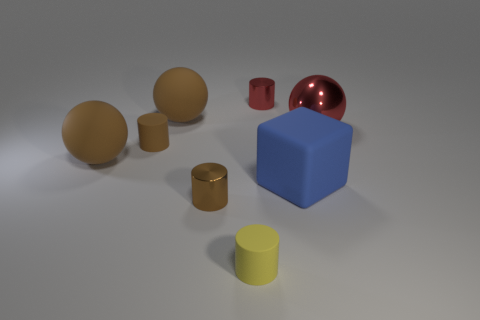How many large brown objects are there?
Give a very brief answer. 2. The small rubber cylinder that is in front of the blue block is what color?
Ensure brevity in your answer.  Yellow. The brown metal cylinder has what size?
Keep it short and to the point. Small. There is a rubber block; is its color the same as the tiny metal cylinder in front of the block?
Your response must be concise. No. There is a tiny shiny thing that is behind the rubber cylinder behind the big blue cube; what color is it?
Offer a very short reply. Red. Does the red metal object to the left of the blue block have the same shape as the small brown metal thing?
Offer a very short reply. Yes. How many big matte things are left of the blue matte cube and in front of the brown rubber cylinder?
Offer a very short reply. 1. What is the color of the tiny rubber cylinder in front of the rubber cylinder that is behind the small metallic object that is left of the red cylinder?
Your answer should be very brief. Yellow. What number of brown objects are in front of the blue thing behind the yellow rubber object?
Your response must be concise. 1. How many other objects are the same shape as the tiny yellow rubber thing?
Your response must be concise. 3. 